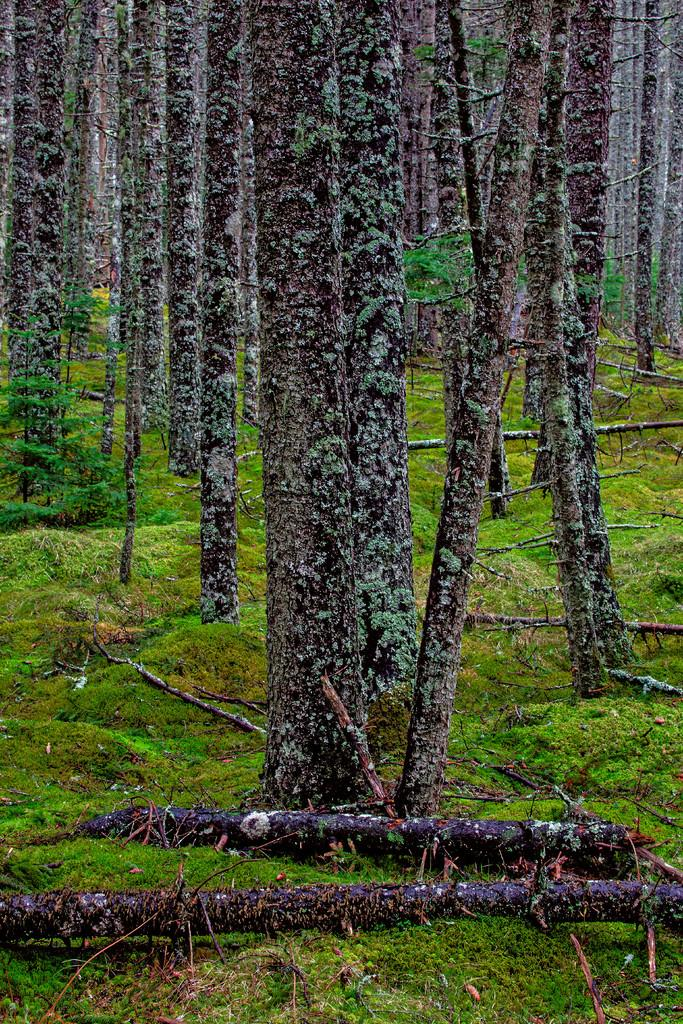What type of surface is visible in the image? There is a grass surface in the image. What other natural elements can be seen in the image? There are trees in the image. Can you describe the setting of the image? The image features a grass surface and trees, suggesting a natural or outdoor setting. What type of headwear is being worn by the trees in the image? There are no people or headwear present in the image; it features a grass surface and trees. 